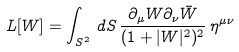Convert formula to latex. <formula><loc_0><loc_0><loc_500><loc_500>L [ W ] = \int _ { S ^ { 2 } } \, d S \, \frac { \partial _ { \mu } W \partial _ { \nu } \bar { W } } { ( 1 + | W | ^ { 2 } ) ^ { 2 } } \, \eta ^ { \mu \nu }</formula> 